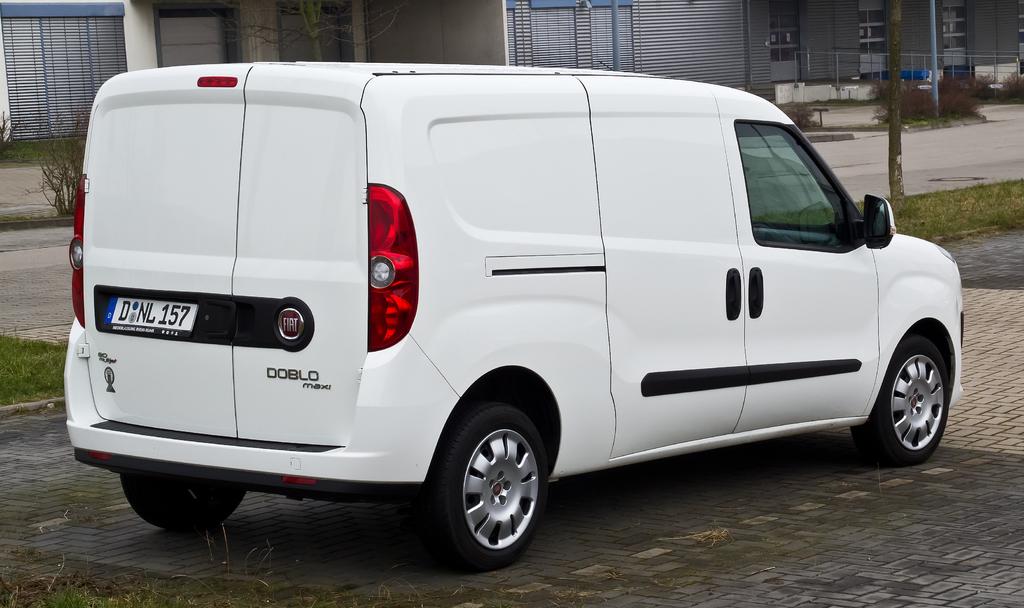What is the license plate number?
Offer a very short reply. Dnl157. 